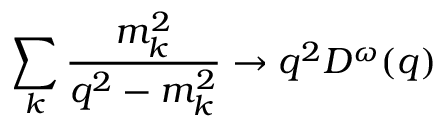Convert formula to latex. <formula><loc_0><loc_0><loc_500><loc_500>\sum _ { k } \frac { m _ { k } ^ { 2 } } { q ^ { 2 } - m _ { k } ^ { 2 } } \rightarrow q ^ { 2 } D ^ { \omega } ( q )</formula> 